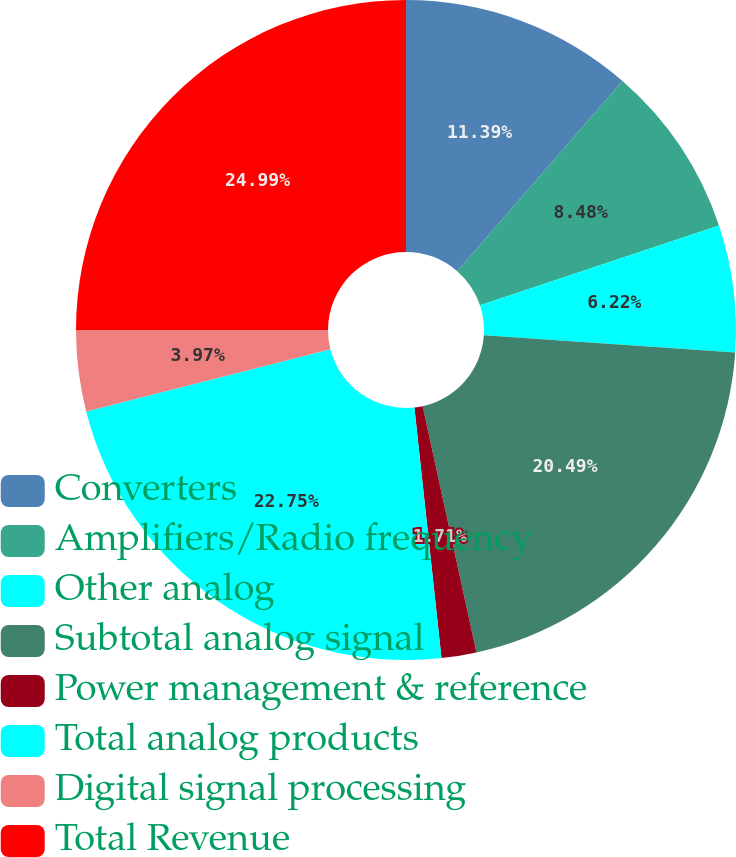Convert chart to OTSL. <chart><loc_0><loc_0><loc_500><loc_500><pie_chart><fcel>Converters<fcel>Amplifiers/Radio frequency<fcel>Other analog<fcel>Subtotal analog signal<fcel>Power management & reference<fcel>Total analog products<fcel>Digital signal processing<fcel>Total Revenue<nl><fcel>11.39%<fcel>8.48%<fcel>6.22%<fcel>20.49%<fcel>1.71%<fcel>22.75%<fcel>3.97%<fcel>25.0%<nl></chart> 